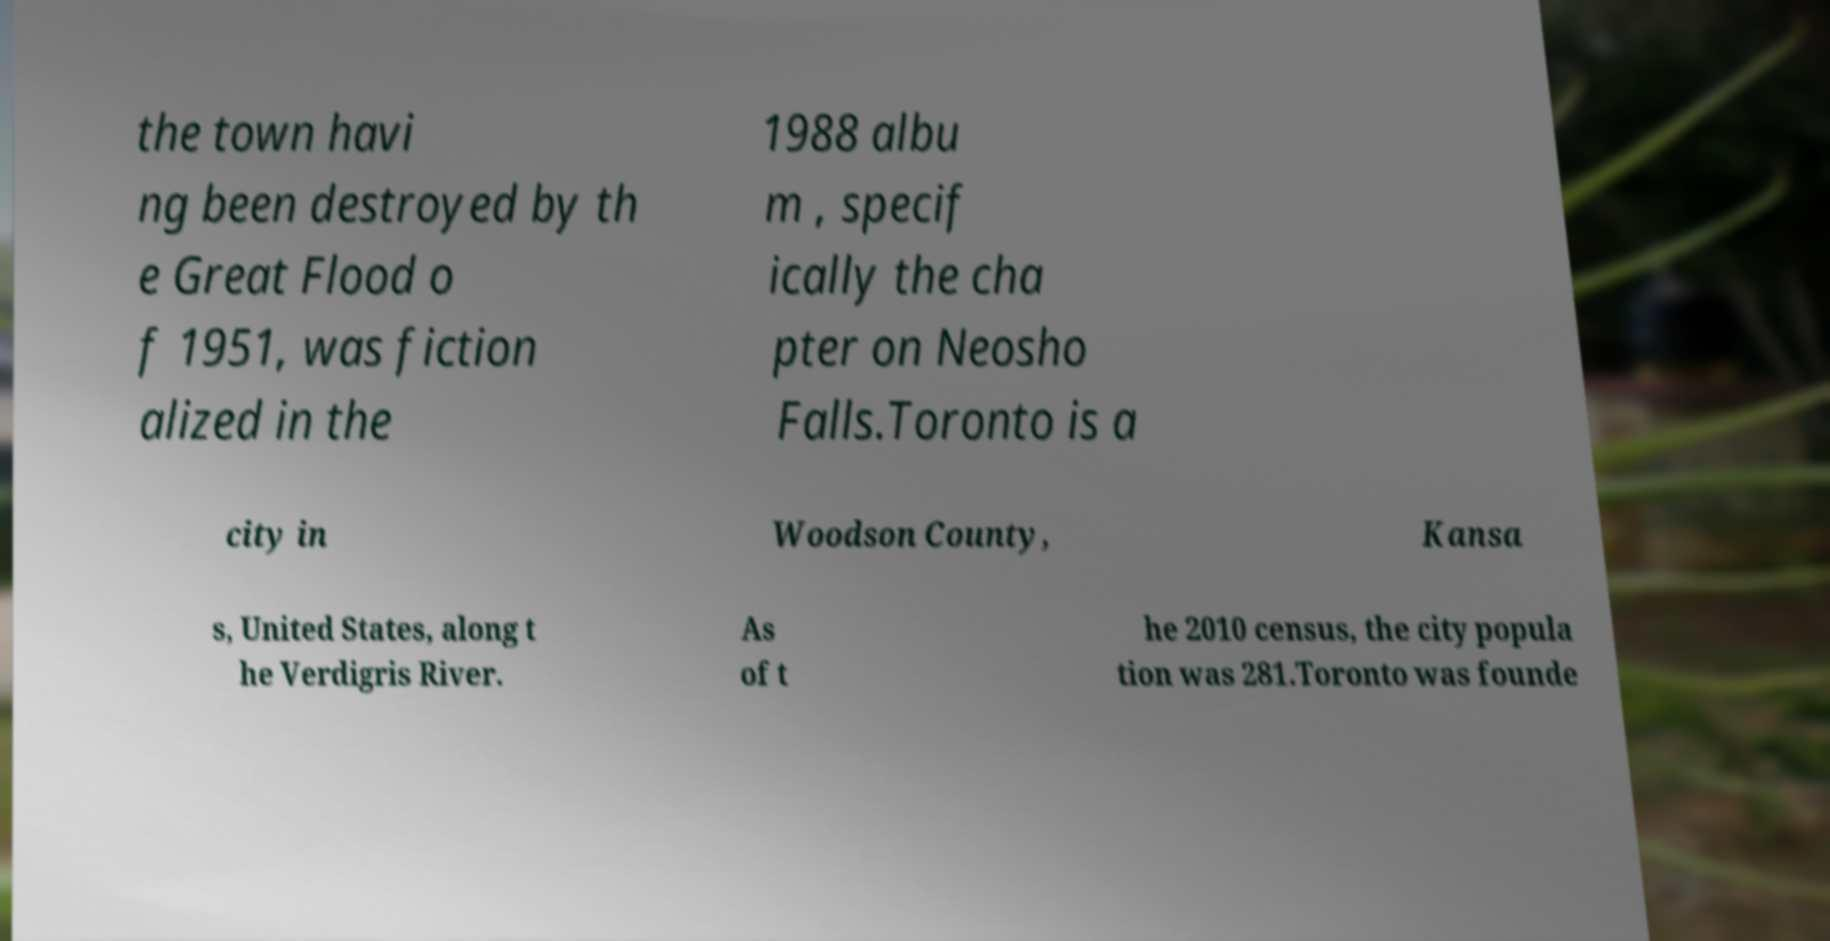Could you extract and type out the text from this image? the town havi ng been destroyed by th e Great Flood o f 1951, was fiction alized in the 1988 albu m , specif ically the cha pter on Neosho Falls.Toronto is a city in Woodson County, Kansa s, United States, along t he Verdigris River. As of t he 2010 census, the city popula tion was 281.Toronto was founde 